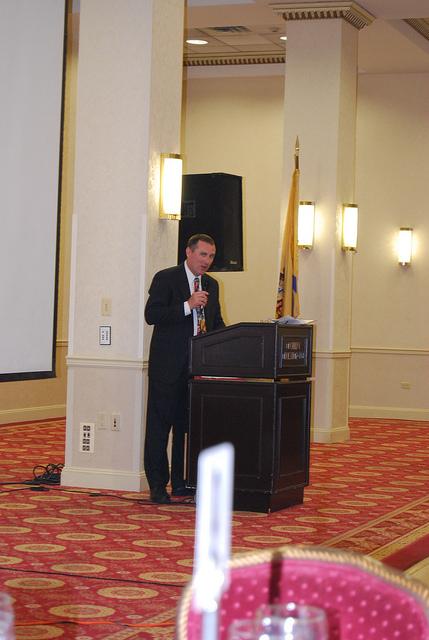What shape is the table in the foreground?
Keep it brief. Round. What color is the flag?
Answer briefly. Yellow. Who is speaking?
Answer briefly. Man. Is there a window in the room?
Concise answer only. No. 